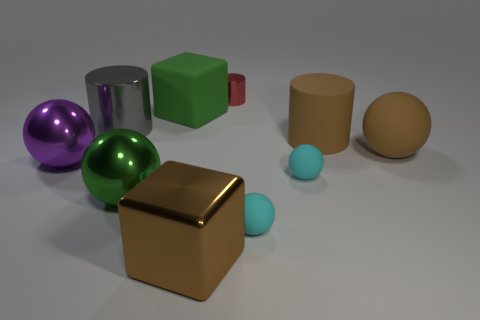Are any small cyan rubber balls visible? Yes, there are two small cyan rubber balls in the image, positioned toward the front, slightly to the left of the center. 